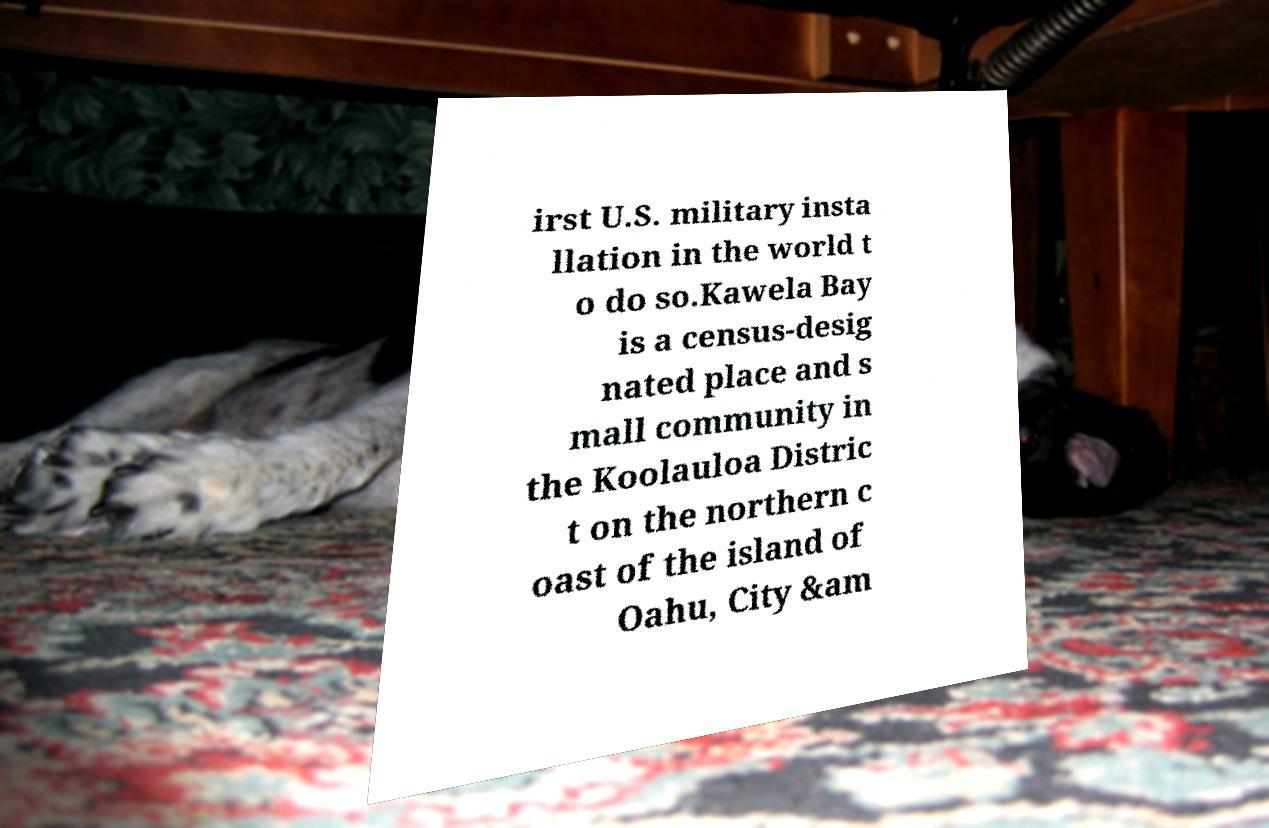Can you accurately transcribe the text from the provided image for me? irst U.S. military insta llation in the world t o do so.Kawela Bay is a census-desig nated place and s mall community in the Koolauloa Distric t on the northern c oast of the island of Oahu, City &am 